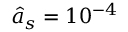Convert formula to latex. <formula><loc_0><loc_0><loc_500><loc_500>\hat { a } _ { s } = 1 0 ^ { - 4 }</formula> 